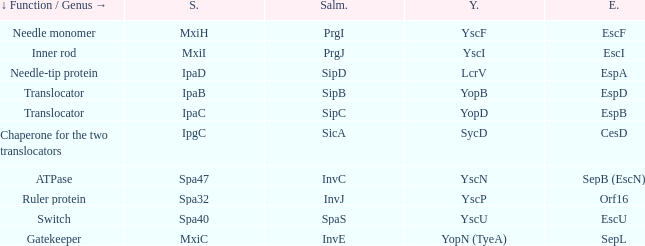Tell me the shigella and yscn Spa47. 